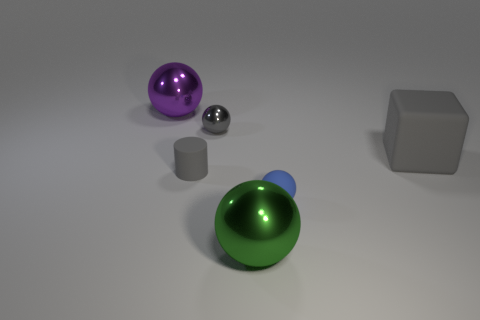Subtract all brown cubes. Subtract all green spheres. How many cubes are left? 1 Add 3 big gray objects. How many objects exist? 9 Subtract all balls. How many objects are left? 2 Subtract all tiny brown matte blocks. Subtract all tiny cylinders. How many objects are left? 5 Add 5 big things. How many big things are left? 8 Add 4 large metallic spheres. How many large metallic spheres exist? 6 Subtract 0 green cylinders. How many objects are left? 6 